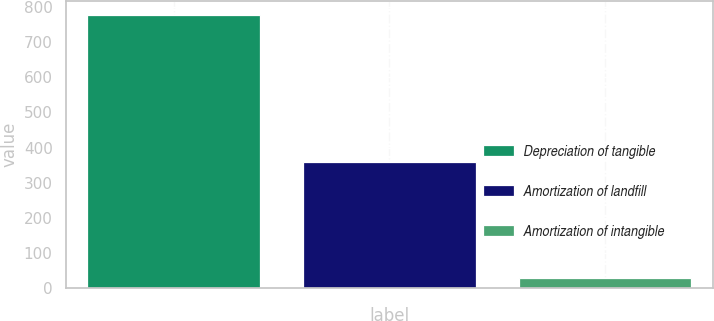<chart> <loc_0><loc_0><loc_500><loc_500><bar_chart><fcel>Depreciation of tangible<fcel>Amortization of landfill<fcel>Amortization of intangible<nl><fcel>779<fcel>358<fcel>29<nl></chart> 